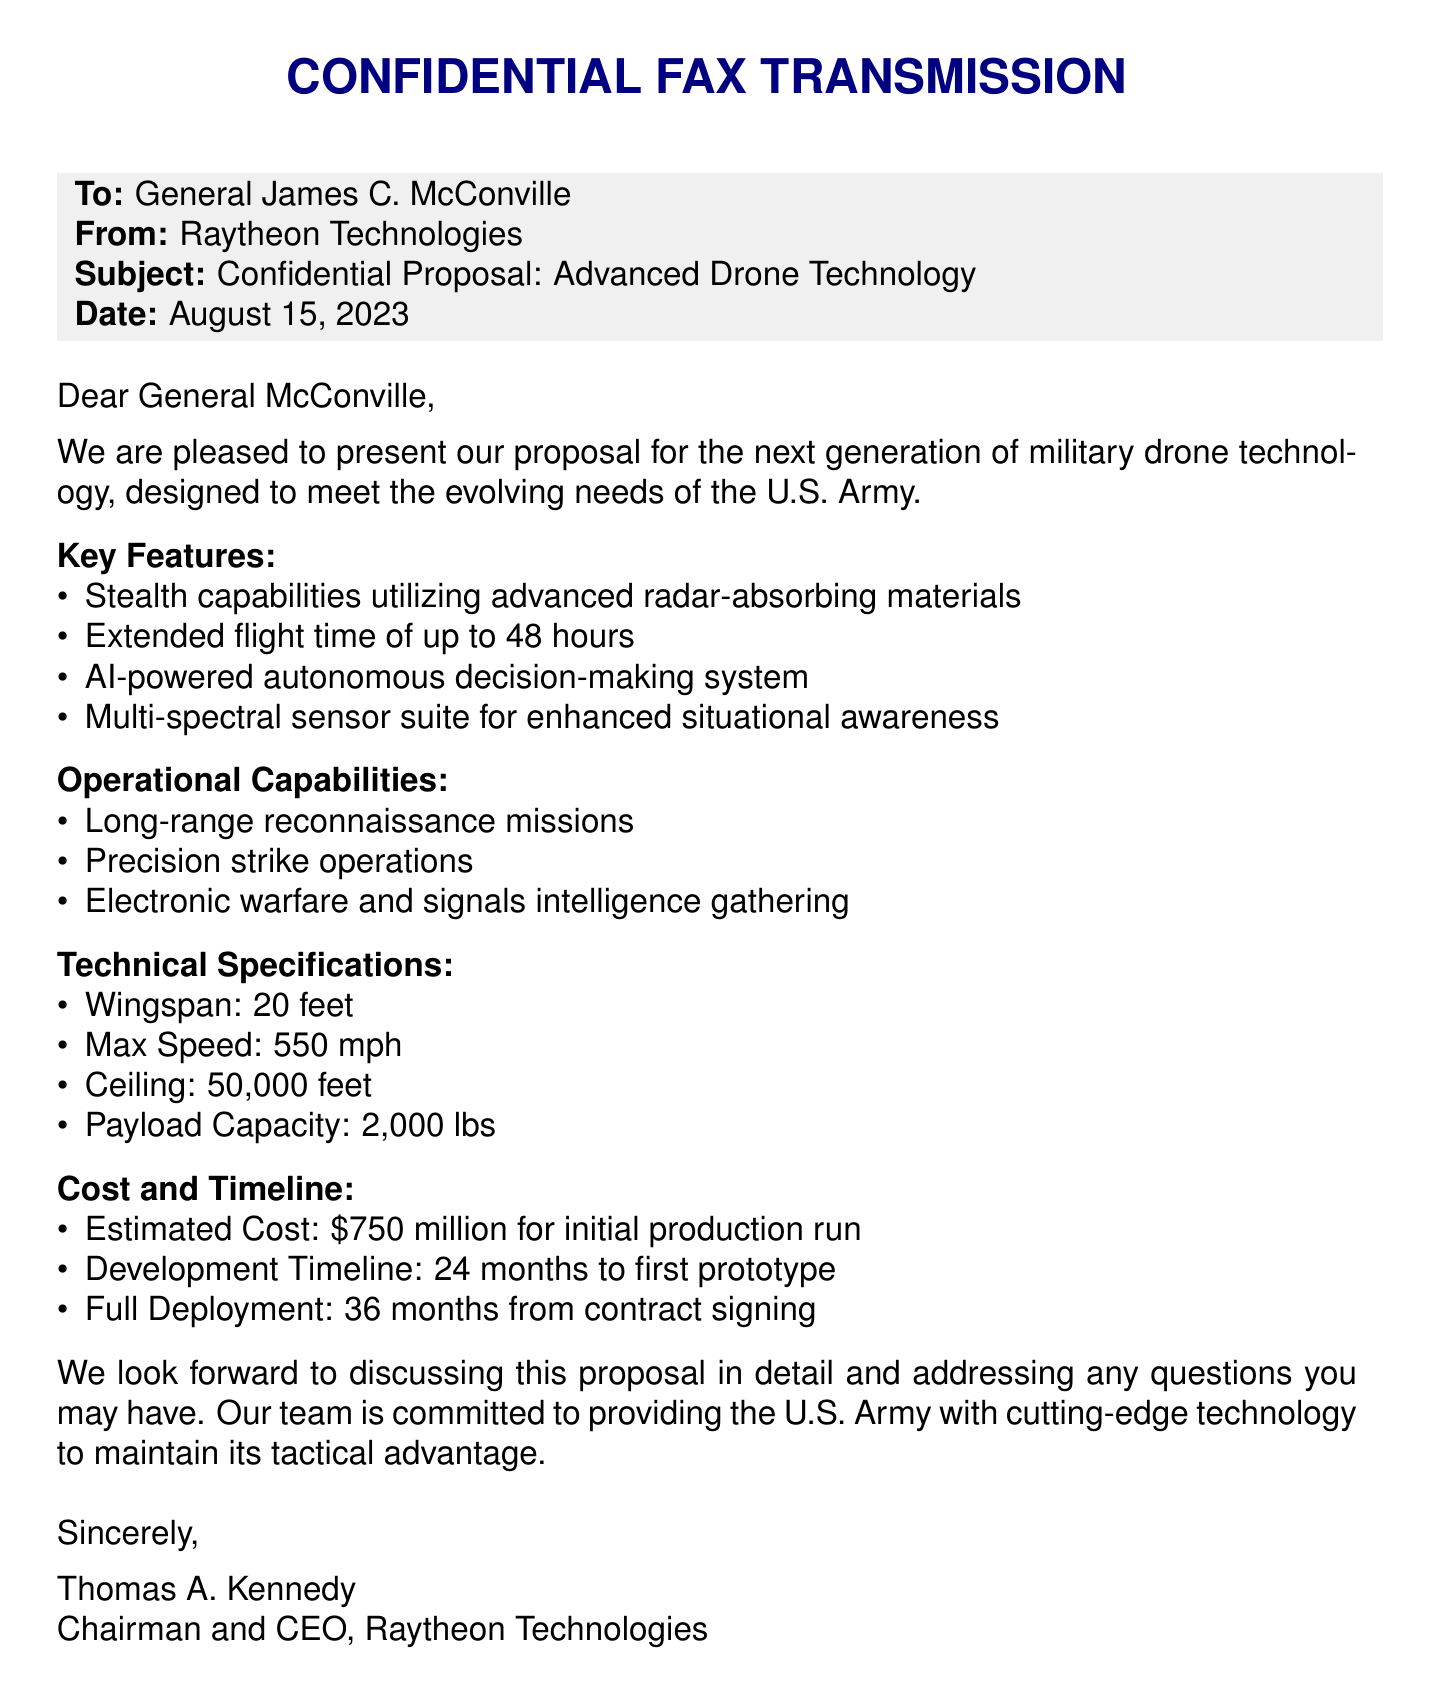What is the date of the fax? The date of the fax is stated clearly in the document header.
Answer: August 15, 2023 Who is the sender of the fax? The sender's information is provided at the top of the document.
Answer: Raytheon Technologies What is the estimated cost for the initial production run? The estimated cost appears in the section regarding cost and timeline.
Answer: $750 million What is the wingspan of the drone? The wingspan is listed under the technical specifications section of the proposal.
Answer: 20 feet What is one of the operational capabilities of the proposed drone? The operational capabilities are highlighted in a dedicated section.
Answer: Long-range reconnaissance missions How long is the development timeline for the first prototype? The development timeline can be found in the cost and timeline section of the document.
Answer: 24 months What type of decision-making system is incorporated in the drone? The type of decision-making system is mentioned in the key features of the document.
Answer: AI-powered autonomous decision-making system What is the maximum speed of the drone? The maximum speed appears in the technical specifications portion of the document.
Answer: 550 mph 